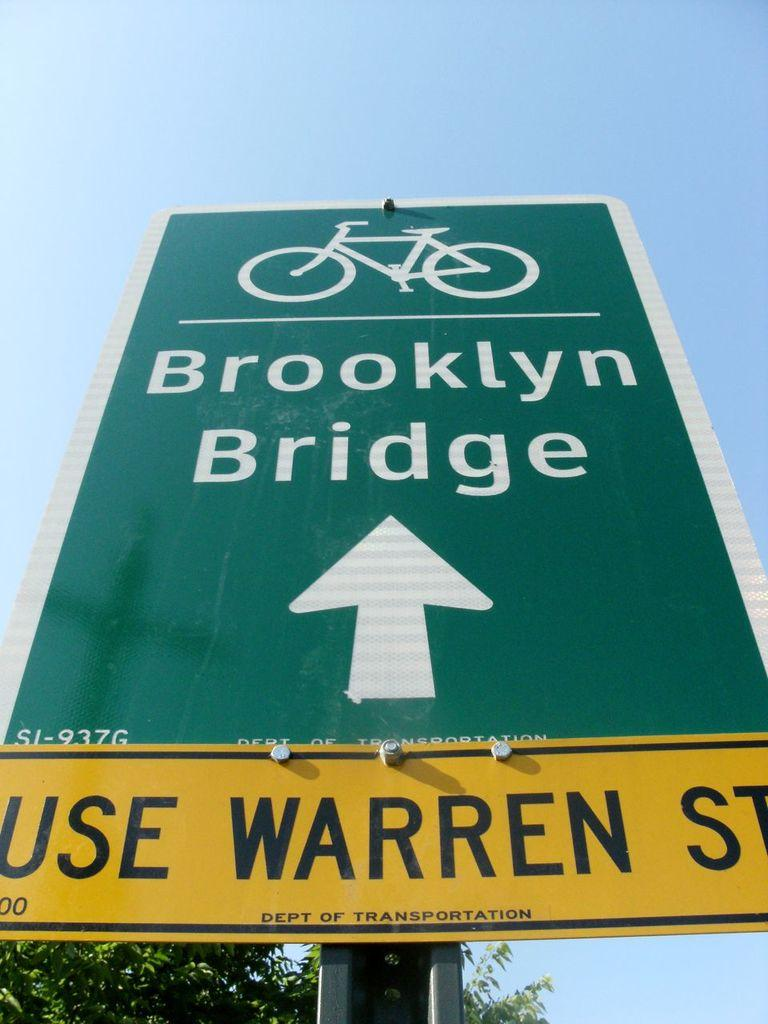<image>
Provide a brief description of the given image. a sign for the Brooklyn Bridge says to Use Warren ST 